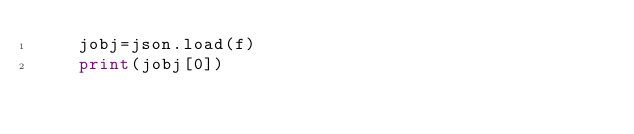<code> <loc_0><loc_0><loc_500><loc_500><_Python_>    jobj=json.load(f)
    print(jobj[0])</code> 